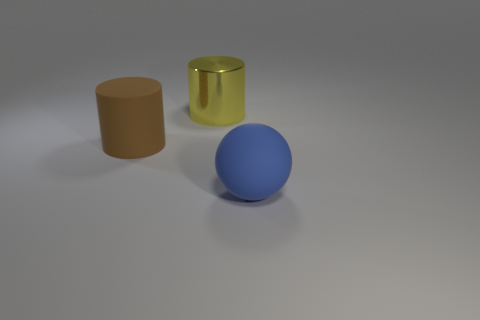Are there any other things that are the same material as the big yellow cylinder?
Offer a terse response. No. There is a big matte thing left of the large yellow cylinder; how many rubber cylinders are right of it?
Ensure brevity in your answer.  0. There is another thing that is the same shape as the yellow shiny thing; what is its color?
Your answer should be very brief. Brown. Does the blue sphere have the same material as the large brown cylinder?
Make the answer very short. Yes. What number of balls are either big brown objects or shiny objects?
Make the answer very short. 0. There is a thing that is to the left of the large metal object behind the brown object left of the yellow metal cylinder; how big is it?
Provide a short and direct response. Large. There is another object that is the same shape as the big brown matte thing; what size is it?
Keep it short and to the point. Large. There is a big rubber cylinder; how many big yellow metal cylinders are in front of it?
Give a very brief answer. 0. There is a matte object to the right of the yellow cylinder; is its color the same as the large rubber cylinder?
Offer a terse response. No. How many cyan things are either big matte cylinders or balls?
Provide a short and direct response. 0. 